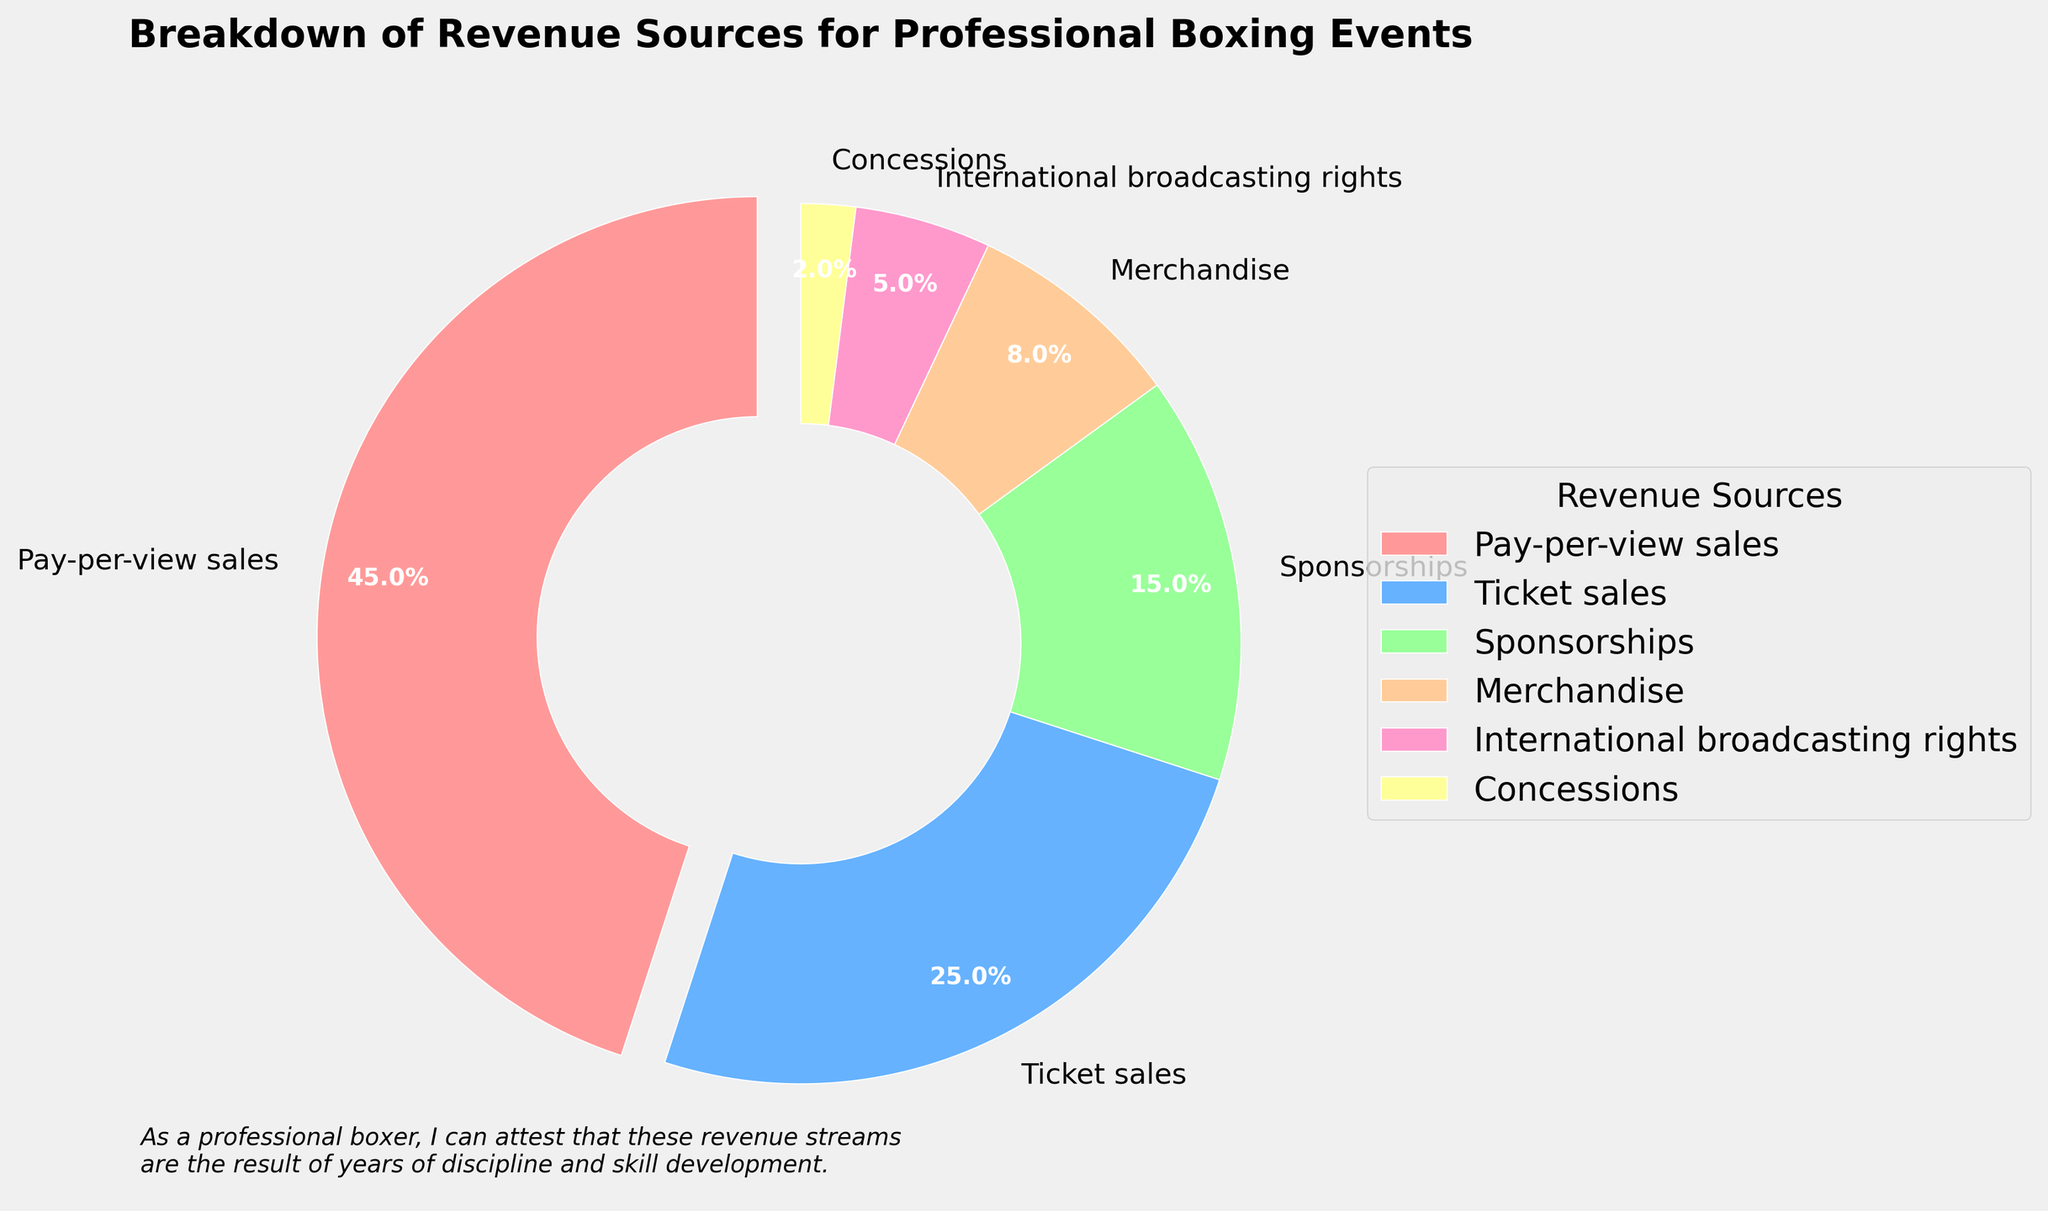Which revenue source contributes the most to the overall revenue? The pie chart shows that Pay-per-view sales have the largest portion of the pie, represented by the biggest wedge.
Answer: Pay-per-view sales Which revenue source has the smallest contribution to the overall revenue? The smallest wedge in the pie chart represents Concessions, indicating it has the lowest percentage.
Answer: Concessions What is the total percentage of revenue generated from Ticket sales and Sponsorships combined? Adding the percentages of Ticket sales (25) and Sponsorships (15) together gives us the combined total.
Answer: 40% Is Merchandise revenue greater than International broadcasting rights revenue? Comparing the size of the wedges, Merchandise (8%) is greater than International broadcasting rights (5%).
Answer: Yes How much more revenue does Pay-per-view sales generate compared to Merchandise? Subtract the percentage of Merchandise (8%) from Pay-per-view sales (45%).
Answer: 37% What are the three largest sources of revenue? The three largest wedges in the pie chart are for Pay-per-view sales (45%), Ticket sales (25%), and Sponsorships (15%).
Answer: Pay-per-view sales, Ticket sales, Sponsorships Which revenue source has a percentage approximately twice that of Sponsorships? Ticket sales have a percentage of 25%, which is approximately twice that of Sponsorships (15%).
Answer: Ticket sales If Sponsorships and Merchandise revenue percentages are combined, will they exceed Ticket sales revenue? Adding the percentages of Sponsorships (15%) and Merchandise (8%) gives 23%, which is less than Ticket sales (25%).
Answer: No What is the combined percentage of the three least contributing revenue sources? Adding the percentages of Merchandise (8%), International broadcasting rights (5%), and Concessions (2%) gives us the combined total.
Answer: 15% What color is used to represent the Pay-per-view sales wedge? The wedge representing Pay-per-view sales is colored in a distinct, light pinkish-red shade.
Answer: Light pinkish-red 